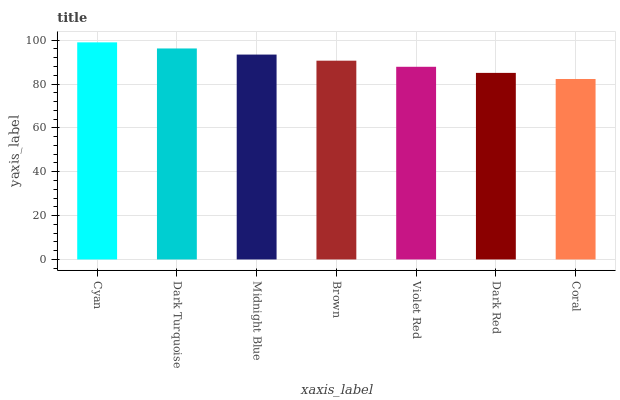Is Coral the minimum?
Answer yes or no. Yes. Is Cyan the maximum?
Answer yes or no. Yes. Is Dark Turquoise the minimum?
Answer yes or no. No. Is Dark Turquoise the maximum?
Answer yes or no. No. Is Cyan greater than Dark Turquoise?
Answer yes or no. Yes. Is Dark Turquoise less than Cyan?
Answer yes or no. Yes. Is Dark Turquoise greater than Cyan?
Answer yes or no. No. Is Cyan less than Dark Turquoise?
Answer yes or no. No. Is Brown the high median?
Answer yes or no. Yes. Is Brown the low median?
Answer yes or no. Yes. Is Coral the high median?
Answer yes or no. No. Is Coral the low median?
Answer yes or no. No. 